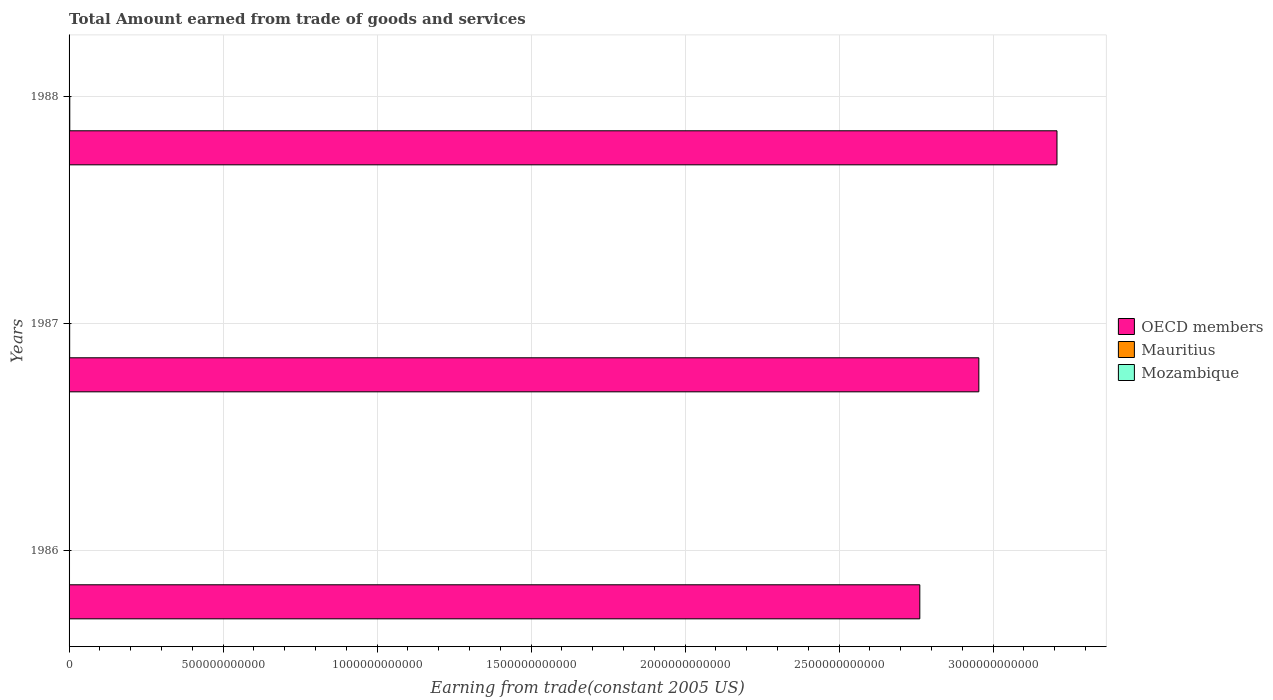How many different coloured bars are there?
Keep it short and to the point. 3. Are the number of bars per tick equal to the number of legend labels?
Your response must be concise. Yes. Are the number of bars on each tick of the Y-axis equal?
Provide a succinct answer. Yes. What is the label of the 2nd group of bars from the top?
Provide a succinct answer. 1987. In how many cases, is the number of bars for a given year not equal to the number of legend labels?
Offer a terse response. 0. What is the total amount earned by trading goods and services in OECD members in 1987?
Keep it short and to the point. 2.95e+12. Across all years, what is the maximum total amount earned by trading goods and services in OECD members?
Keep it short and to the point. 3.21e+12. Across all years, what is the minimum total amount earned by trading goods and services in Mauritius?
Make the answer very short. 1.42e+09. What is the total total amount earned by trading goods and services in OECD members in the graph?
Your answer should be very brief. 8.92e+12. What is the difference between the total amount earned by trading goods and services in Mauritius in 1986 and that in 1988?
Provide a succinct answer. -8.90e+08. What is the difference between the total amount earned by trading goods and services in Mozambique in 1987 and the total amount earned by trading goods and services in Mauritius in 1986?
Make the answer very short. -2.01e+08. What is the average total amount earned by trading goods and services in Mozambique per year?
Provide a succinct answer. 1.20e+09. In the year 1987, what is the difference between the total amount earned by trading goods and services in Mauritius and total amount earned by trading goods and services in OECD members?
Provide a short and direct response. -2.95e+12. What is the ratio of the total amount earned by trading goods and services in Mozambique in 1986 to that in 1988?
Give a very brief answer. 0.98. Is the difference between the total amount earned by trading goods and services in Mauritius in 1986 and 1987 greater than the difference between the total amount earned by trading goods and services in OECD members in 1986 and 1987?
Offer a terse response. Yes. What is the difference between the highest and the second highest total amount earned by trading goods and services in Mozambique?
Make the answer very short. 2.81e+07. What is the difference between the highest and the lowest total amount earned by trading goods and services in Mozambique?
Provide a succinct answer. 4.86e+07. Is the sum of the total amount earned by trading goods and services in Mauritius in 1986 and 1988 greater than the maximum total amount earned by trading goods and services in Mozambique across all years?
Keep it short and to the point. Yes. What does the 2nd bar from the bottom in 1987 represents?
Make the answer very short. Mauritius. Is it the case that in every year, the sum of the total amount earned by trading goods and services in OECD members and total amount earned by trading goods and services in Mauritius is greater than the total amount earned by trading goods and services in Mozambique?
Your response must be concise. Yes. How many bars are there?
Ensure brevity in your answer.  9. Are all the bars in the graph horizontal?
Your response must be concise. Yes. What is the difference between two consecutive major ticks on the X-axis?
Offer a terse response. 5.00e+11. Does the graph contain any zero values?
Offer a terse response. No. How many legend labels are there?
Offer a very short reply. 3. How are the legend labels stacked?
Provide a short and direct response. Vertical. What is the title of the graph?
Provide a short and direct response. Total Amount earned from trade of goods and services. What is the label or title of the X-axis?
Your answer should be very brief. Earning from trade(constant 2005 US). What is the label or title of the Y-axis?
Your answer should be compact. Years. What is the Earning from trade(constant 2005 US) in OECD members in 1986?
Provide a succinct answer. 2.76e+12. What is the Earning from trade(constant 2005 US) of Mauritius in 1986?
Keep it short and to the point. 1.42e+09. What is the Earning from trade(constant 2005 US) of Mozambique in 1986?
Your answer should be very brief. 1.17e+09. What is the Earning from trade(constant 2005 US) in OECD members in 1987?
Offer a very short reply. 2.95e+12. What is the Earning from trade(constant 2005 US) in Mauritius in 1987?
Your answer should be compact. 1.93e+09. What is the Earning from trade(constant 2005 US) in Mozambique in 1987?
Keep it short and to the point. 1.22e+09. What is the Earning from trade(constant 2005 US) in OECD members in 1988?
Keep it short and to the point. 3.21e+12. What is the Earning from trade(constant 2005 US) in Mauritius in 1988?
Ensure brevity in your answer.  2.31e+09. What is the Earning from trade(constant 2005 US) in Mozambique in 1988?
Your answer should be very brief. 1.20e+09. Across all years, what is the maximum Earning from trade(constant 2005 US) of OECD members?
Your answer should be very brief. 3.21e+12. Across all years, what is the maximum Earning from trade(constant 2005 US) in Mauritius?
Your response must be concise. 2.31e+09. Across all years, what is the maximum Earning from trade(constant 2005 US) of Mozambique?
Keep it short and to the point. 1.22e+09. Across all years, what is the minimum Earning from trade(constant 2005 US) of OECD members?
Give a very brief answer. 2.76e+12. Across all years, what is the minimum Earning from trade(constant 2005 US) of Mauritius?
Keep it short and to the point. 1.42e+09. Across all years, what is the minimum Earning from trade(constant 2005 US) in Mozambique?
Keep it short and to the point. 1.17e+09. What is the total Earning from trade(constant 2005 US) of OECD members in the graph?
Offer a terse response. 8.92e+12. What is the total Earning from trade(constant 2005 US) in Mauritius in the graph?
Your answer should be very brief. 5.67e+09. What is the total Earning from trade(constant 2005 US) in Mozambique in the graph?
Provide a short and direct response. 3.59e+09. What is the difference between the Earning from trade(constant 2005 US) of OECD members in 1986 and that in 1987?
Provide a succinct answer. -1.92e+11. What is the difference between the Earning from trade(constant 2005 US) of Mauritius in 1986 and that in 1987?
Your answer should be compact. -5.06e+08. What is the difference between the Earning from trade(constant 2005 US) in Mozambique in 1986 and that in 1987?
Provide a short and direct response. -4.86e+07. What is the difference between the Earning from trade(constant 2005 US) of OECD members in 1986 and that in 1988?
Give a very brief answer. -4.45e+11. What is the difference between the Earning from trade(constant 2005 US) of Mauritius in 1986 and that in 1988?
Offer a very short reply. -8.90e+08. What is the difference between the Earning from trade(constant 2005 US) of Mozambique in 1986 and that in 1988?
Your answer should be compact. -2.05e+07. What is the difference between the Earning from trade(constant 2005 US) of OECD members in 1987 and that in 1988?
Your answer should be compact. -2.54e+11. What is the difference between the Earning from trade(constant 2005 US) in Mauritius in 1987 and that in 1988?
Your answer should be very brief. -3.84e+08. What is the difference between the Earning from trade(constant 2005 US) in Mozambique in 1987 and that in 1988?
Give a very brief answer. 2.81e+07. What is the difference between the Earning from trade(constant 2005 US) of OECD members in 1986 and the Earning from trade(constant 2005 US) of Mauritius in 1987?
Keep it short and to the point. 2.76e+12. What is the difference between the Earning from trade(constant 2005 US) of OECD members in 1986 and the Earning from trade(constant 2005 US) of Mozambique in 1987?
Provide a short and direct response. 2.76e+12. What is the difference between the Earning from trade(constant 2005 US) in Mauritius in 1986 and the Earning from trade(constant 2005 US) in Mozambique in 1987?
Give a very brief answer. 2.01e+08. What is the difference between the Earning from trade(constant 2005 US) of OECD members in 1986 and the Earning from trade(constant 2005 US) of Mauritius in 1988?
Make the answer very short. 2.76e+12. What is the difference between the Earning from trade(constant 2005 US) in OECD members in 1986 and the Earning from trade(constant 2005 US) in Mozambique in 1988?
Offer a terse response. 2.76e+12. What is the difference between the Earning from trade(constant 2005 US) of Mauritius in 1986 and the Earning from trade(constant 2005 US) of Mozambique in 1988?
Make the answer very short. 2.29e+08. What is the difference between the Earning from trade(constant 2005 US) of OECD members in 1987 and the Earning from trade(constant 2005 US) of Mauritius in 1988?
Offer a terse response. 2.95e+12. What is the difference between the Earning from trade(constant 2005 US) of OECD members in 1987 and the Earning from trade(constant 2005 US) of Mozambique in 1988?
Offer a terse response. 2.95e+12. What is the difference between the Earning from trade(constant 2005 US) of Mauritius in 1987 and the Earning from trade(constant 2005 US) of Mozambique in 1988?
Make the answer very short. 7.34e+08. What is the average Earning from trade(constant 2005 US) in OECD members per year?
Ensure brevity in your answer.  2.97e+12. What is the average Earning from trade(constant 2005 US) in Mauritius per year?
Give a very brief answer. 1.89e+09. What is the average Earning from trade(constant 2005 US) of Mozambique per year?
Provide a short and direct response. 1.20e+09. In the year 1986, what is the difference between the Earning from trade(constant 2005 US) in OECD members and Earning from trade(constant 2005 US) in Mauritius?
Provide a short and direct response. 2.76e+12. In the year 1986, what is the difference between the Earning from trade(constant 2005 US) of OECD members and Earning from trade(constant 2005 US) of Mozambique?
Your answer should be very brief. 2.76e+12. In the year 1986, what is the difference between the Earning from trade(constant 2005 US) of Mauritius and Earning from trade(constant 2005 US) of Mozambique?
Offer a terse response. 2.49e+08. In the year 1987, what is the difference between the Earning from trade(constant 2005 US) in OECD members and Earning from trade(constant 2005 US) in Mauritius?
Offer a very short reply. 2.95e+12. In the year 1987, what is the difference between the Earning from trade(constant 2005 US) in OECD members and Earning from trade(constant 2005 US) in Mozambique?
Give a very brief answer. 2.95e+12. In the year 1987, what is the difference between the Earning from trade(constant 2005 US) in Mauritius and Earning from trade(constant 2005 US) in Mozambique?
Keep it short and to the point. 7.06e+08. In the year 1988, what is the difference between the Earning from trade(constant 2005 US) of OECD members and Earning from trade(constant 2005 US) of Mauritius?
Provide a short and direct response. 3.21e+12. In the year 1988, what is the difference between the Earning from trade(constant 2005 US) in OECD members and Earning from trade(constant 2005 US) in Mozambique?
Offer a very short reply. 3.21e+12. In the year 1988, what is the difference between the Earning from trade(constant 2005 US) of Mauritius and Earning from trade(constant 2005 US) of Mozambique?
Keep it short and to the point. 1.12e+09. What is the ratio of the Earning from trade(constant 2005 US) in OECD members in 1986 to that in 1987?
Your answer should be very brief. 0.94. What is the ratio of the Earning from trade(constant 2005 US) of Mauritius in 1986 to that in 1987?
Make the answer very short. 0.74. What is the ratio of the Earning from trade(constant 2005 US) in Mozambique in 1986 to that in 1987?
Your answer should be very brief. 0.96. What is the ratio of the Earning from trade(constant 2005 US) in OECD members in 1986 to that in 1988?
Your response must be concise. 0.86. What is the ratio of the Earning from trade(constant 2005 US) of Mauritius in 1986 to that in 1988?
Ensure brevity in your answer.  0.62. What is the ratio of the Earning from trade(constant 2005 US) in Mozambique in 1986 to that in 1988?
Offer a very short reply. 0.98. What is the ratio of the Earning from trade(constant 2005 US) in OECD members in 1987 to that in 1988?
Offer a very short reply. 0.92. What is the ratio of the Earning from trade(constant 2005 US) of Mauritius in 1987 to that in 1988?
Your response must be concise. 0.83. What is the ratio of the Earning from trade(constant 2005 US) in Mozambique in 1987 to that in 1988?
Keep it short and to the point. 1.02. What is the difference between the highest and the second highest Earning from trade(constant 2005 US) of OECD members?
Provide a short and direct response. 2.54e+11. What is the difference between the highest and the second highest Earning from trade(constant 2005 US) in Mauritius?
Offer a terse response. 3.84e+08. What is the difference between the highest and the second highest Earning from trade(constant 2005 US) of Mozambique?
Your answer should be compact. 2.81e+07. What is the difference between the highest and the lowest Earning from trade(constant 2005 US) of OECD members?
Keep it short and to the point. 4.45e+11. What is the difference between the highest and the lowest Earning from trade(constant 2005 US) in Mauritius?
Ensure brevity in your answer.  8.90e+08. What is the difference between the highest and the lowest Earning from trade(constant 2005 US) of Mozambique?
Your answer should be very brief. 4.86e+07. 